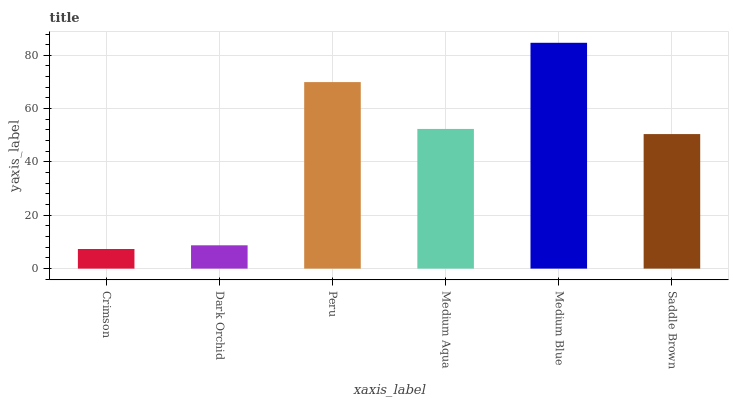Is Dark Orchid the minimum?
Answer yes or no. No. Is Dark Orchid the maximum?
Answer yes or no. No. Is Dark Orchid greater than Crimson?
Answer yes or no. Yes. Is Crimson less than Dark Orchid?
Answer yes or no. Yes. Is Crimson greater than Dark Orchid?
Answer yes or no. No. Is Dark Orchid less than Crimson?
Answer yes or no. No. Is Medium Aqua the high median?
Answer yes or no. Yes. Is Saddle Brown the low median?
Answer yes or no. Yes. Is Saddle Brown the high median?
Answer yes or no. No. Is Medium Blue the low median?
Answer yes or no. No. 